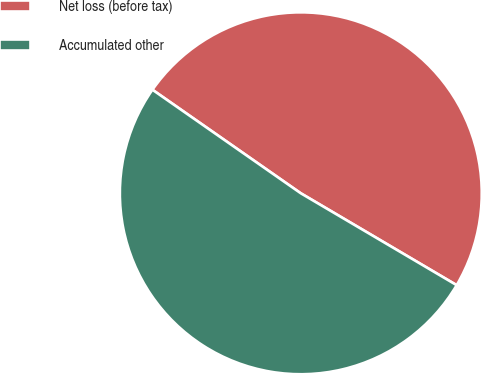<chart> <loc_0><loc_0><loc_500><loc_500><pie_chart><fcel>Net loss (before tax)<fcel>Accumulated other<nl><fcel>48.78%<fcel>51.22%<nl></chart> 